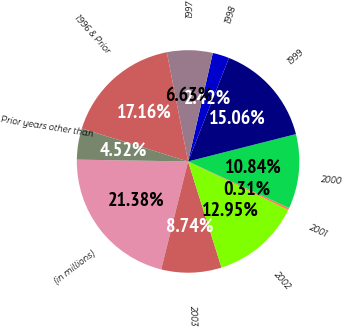Convert chart. <chart><loc_0><loc_0><loc_500><loc_500><pie_chart><fcel>(in millions)<fcel>2003<fcel>2002<fcel>2001<fcel>2000<fcel>1999<fcel>1998<fcel>1997<fcel>1996 & Prior<fcel>Prior years other than<nl><fcel>21.38%<fcel>8.74%<fcel>12.95%<fcel>0.31%<fcel>10.84%<fcel>15.06%<fcel>2.42%<fcel>6.63%<fcel>17.16%<fcel>4.52%<nl></chart> 